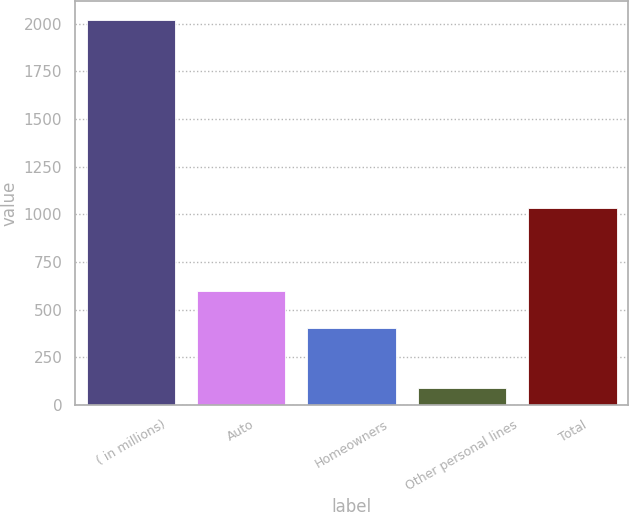<chart> <loc_0><loc_0><loc_500><loc_500><bar_chart><fcel>( in millions)<fcel>Auto<fcel>Homeowners<fcel>Other personal lines<fcel>Total<nl><fcel>2017<fcel>599<fcel>406<fcel>87<fcel>1035<nl></chart> 